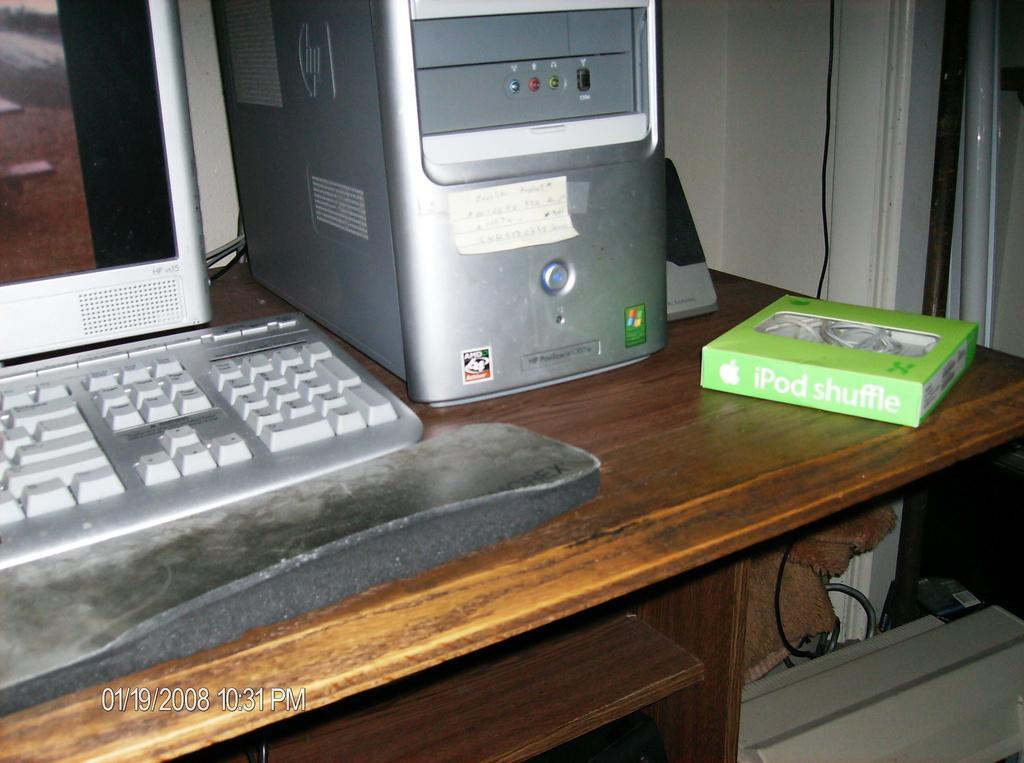Please provide a concise description of this image. There is a monitor keyboard and CPU on table with IPOD shuffle box. 